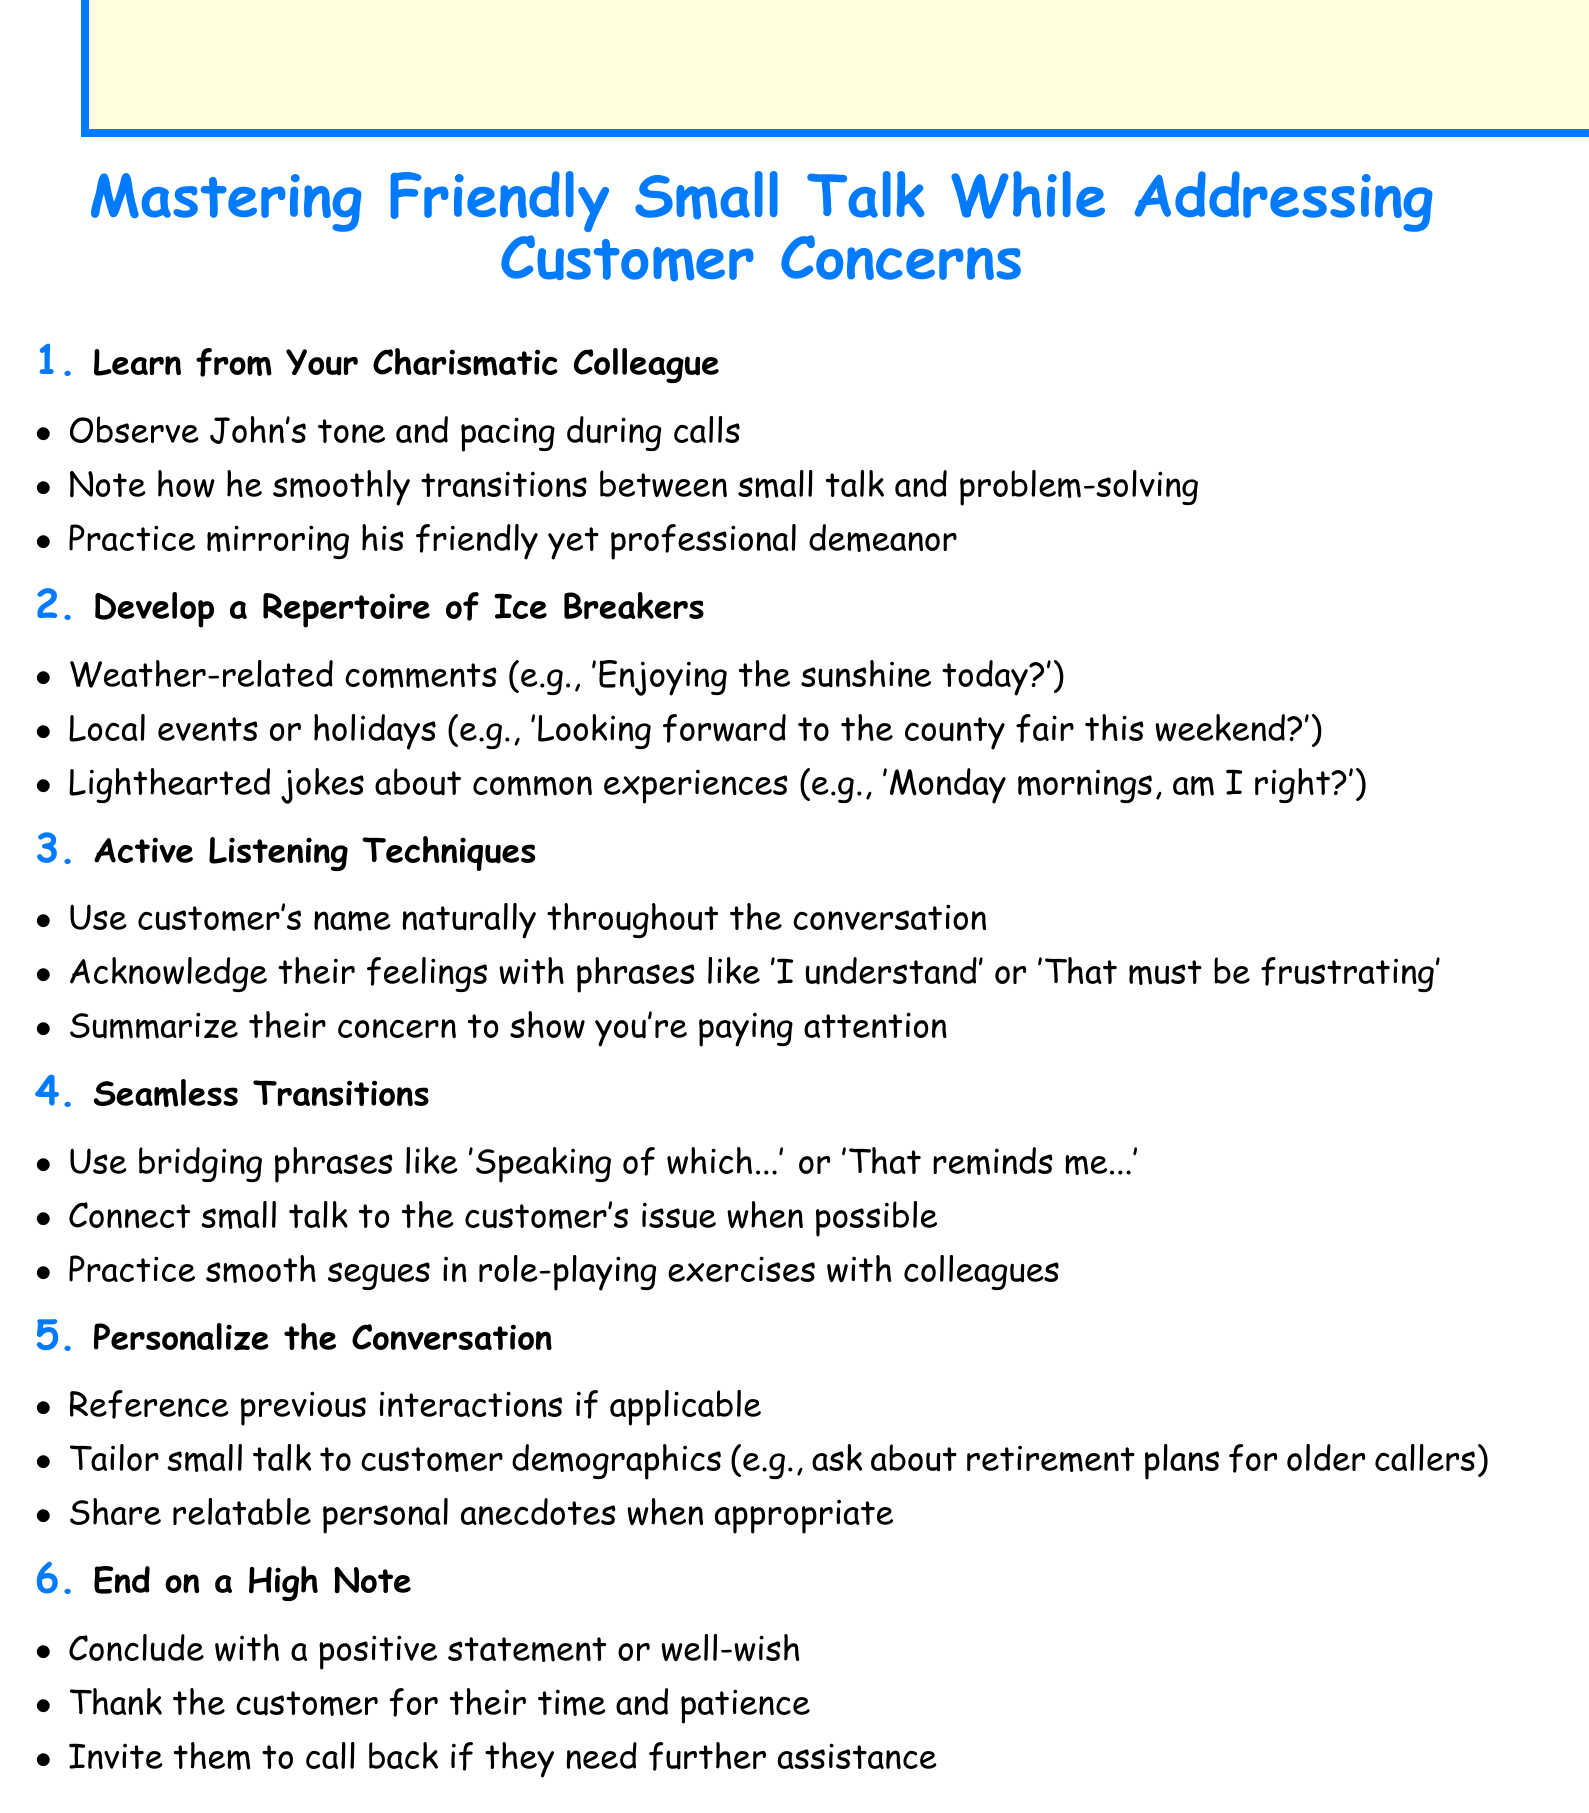What is the title of the document? The title of the document is stated at the very top, which introduces the main theme of the notes.
Answer: Mastering Friendly Small Talk While Addressing Customer Concerns How many sections are in the document? The document contains several section headings, which can be counted to determine the total number of sections.
Answer: 6 What is one example of an ice breaker mentioned? The document lists examples of ice breakers in the second section that can be used to start conversations.
Answer: Enjoying the sunshine today? What is a technique for active listening? The document provides specific techniques for active listening in the third section, responding to customers effectively.
Answer: Use customer's name naturally What is a bridging phrase mentioned for seamless transitions? The document describes seamless transitions and includes specific phrases that can be used in conversation.
Answer: Speaking of which… What should you do at the end of a conversation? The last section of the document mentions strategies for ending customer interactions on a positive note.
Answer: Conclude with a positive statement Which section discusses personalizing the conversation? The document is organized into sections, and one of them specifically highlights how to make conversations more personal.
Answer: 5. Personalize the Conversation What mindset should you adopt while observing your colleague? The first section suggests adopting certain characteristics of a colleague to enhance your phone skills.
Answer: Charismatic What should you thank the customer for? The final points in the last section include gestures of appreciation towards the customers.
Answer: Their time and patience 